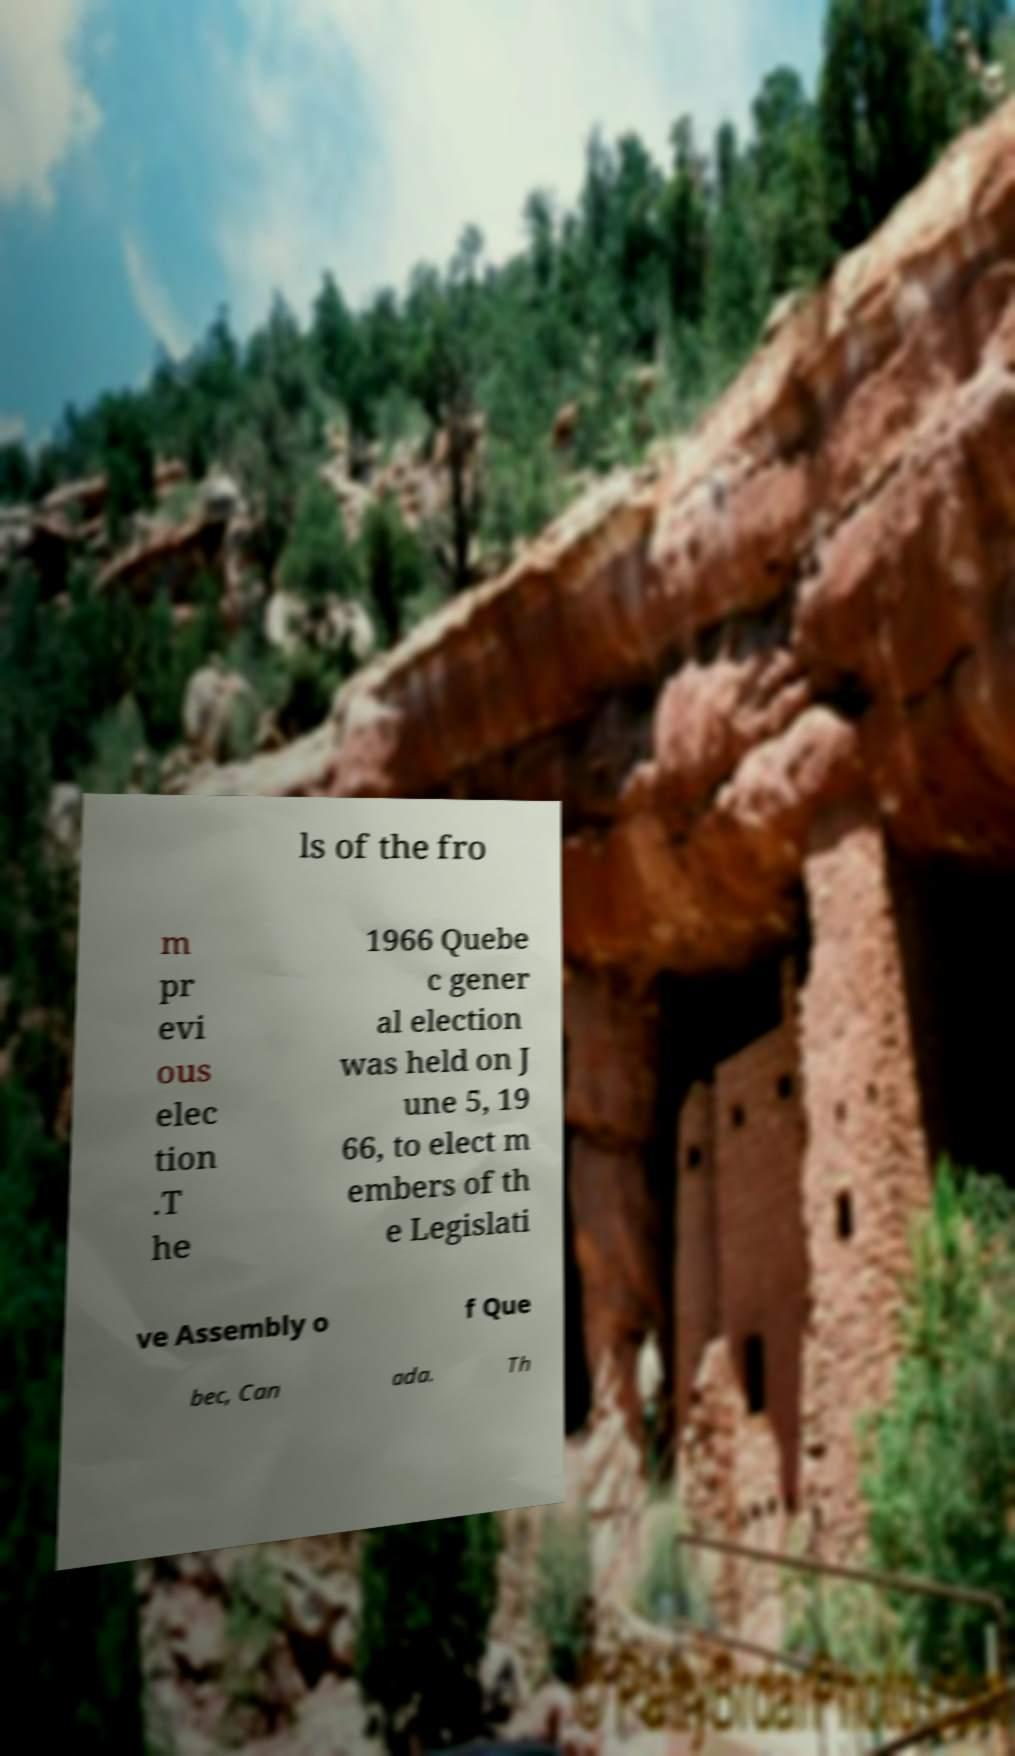Can you accurately transcribe the text from the provided image for me? ls of the fro m pr evi ous elec tion .T he 1966 Quebe c gener al election was held on J une 5, 19 66, to elect m embers of th e Legislati ve Assembly o f Que bec, Can ada. Th 